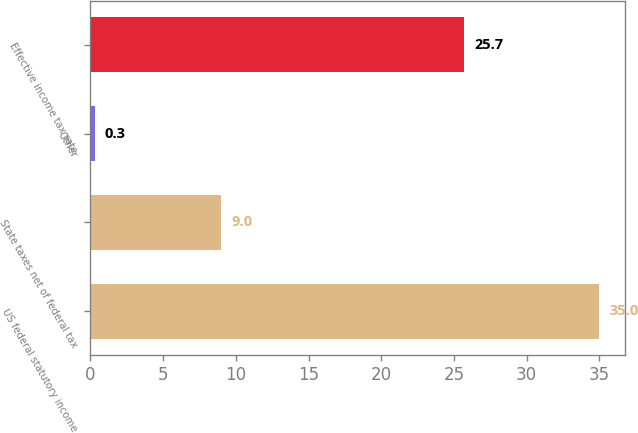Convert chart to OTSL. <chart><loc_0><loc_0><loc_500><loc_500><bar_chart><fcel>US federal statutory income<fcel>State taxes net of federal tax<fcel>Other<fcel>Effective income tax rate<nl><fcel>35<fcel>9<fcel>0.3<fcel>25.7<nl></chart> 